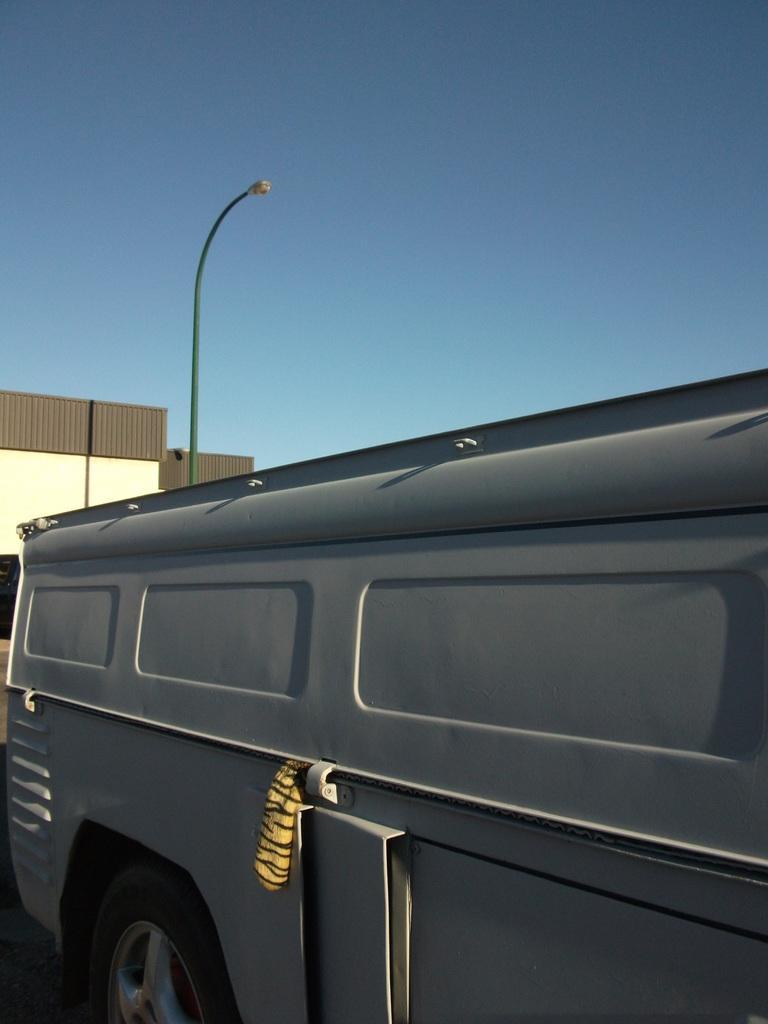Describe this image in one or two sentences. In this picture I can see a vehicle, there is a building, there is a pole with a light, and in the background there is the sky. 